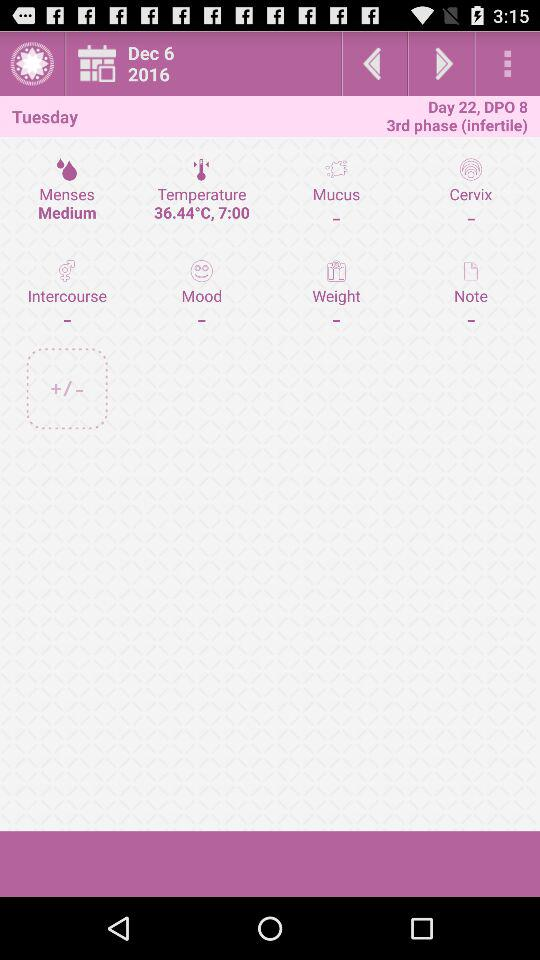What is the day on December 6, 2016? The day is Tuesday. 